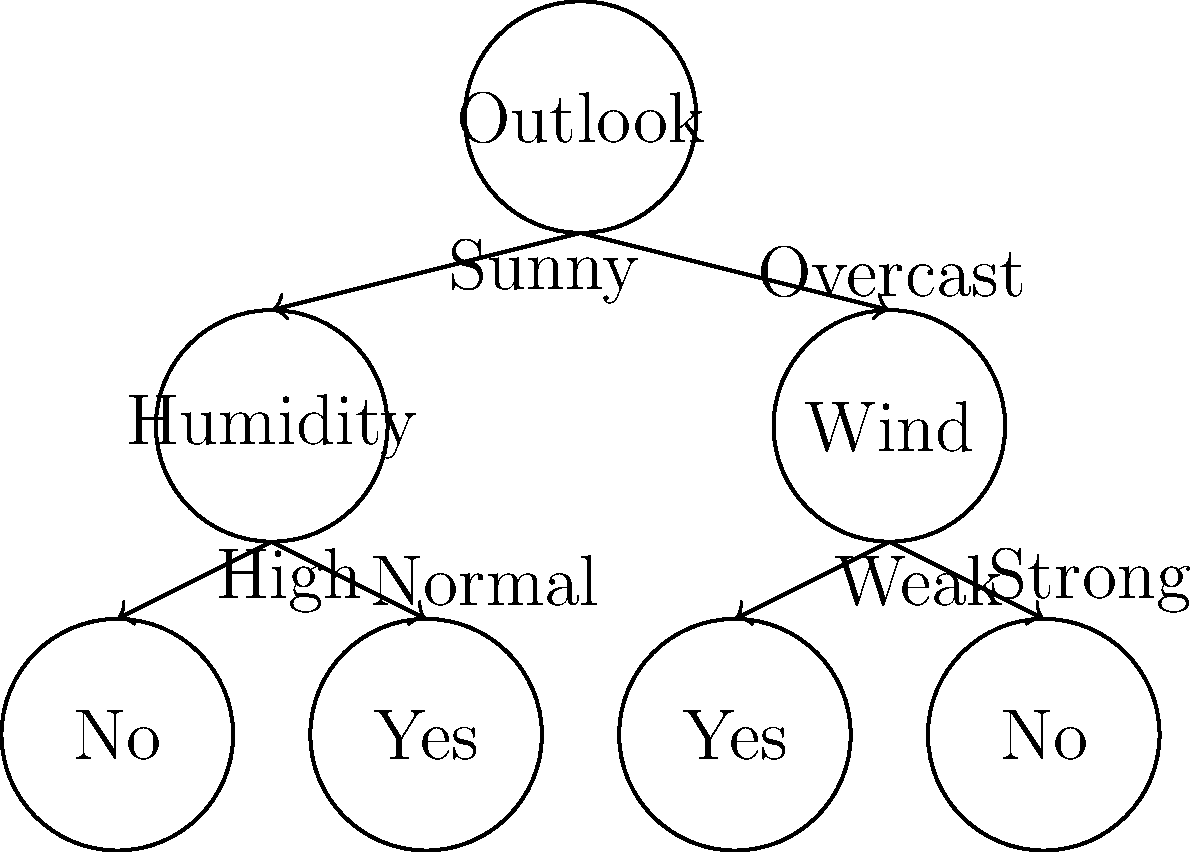Given the decision tree for a classic weather dataset, which feature is the most important for determining whether to play tennis, and what can be inferred about playing tennis when the outlook is overcast? To answer this question, we need to analyze the structure of the decision tree:

1. The root node of the tree is "Outlook," which indicates that this is the most important feature for making the decision. It's the first split in the tree, meaning it provides the most information gain.

2. There are three branches from the root node:
   a. Sunny: leads to a decision based on Humidity
   b. Overcast: leads directly to a leaf node
   c. (Implied) Rainy: leads to a decision based on Wind

3. For the Overcast branch:
   - It leads directly to a "Yes" leaf node without any further splits.
   - This means that when the outlook is overcast, the decision is always to play tennis, regardless of other factors.

4. The other branches (Sunny and Rainy) require additional information (Humidity and Wind, respectively) to make a decision.

Therefore, we can conclude:
1. Outlook is the most important feature for determining whether to play tennis, as it's at the root of the decision tree.
2. When the outlook is overcast, the decision is always to play tennis, without considering any other features.
Answer: Outlook; always play when overcast 